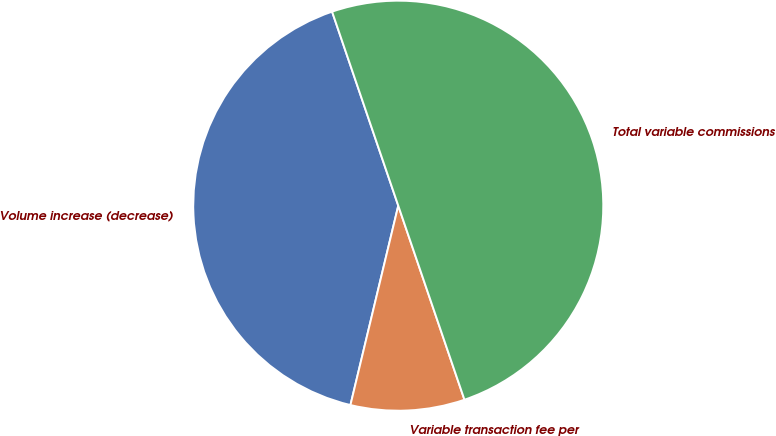Convert chart to OTSL. <chart><loc_0><loc_0><loc_500><loc_500><pie_chart><fcel>Volume increase (decrease)<fcel>Variable transaction fee per<fcel>Total variable commissions<nl><fcel>41.02%<fcel>8.98%<fcel>50.0%<nl></chart> 